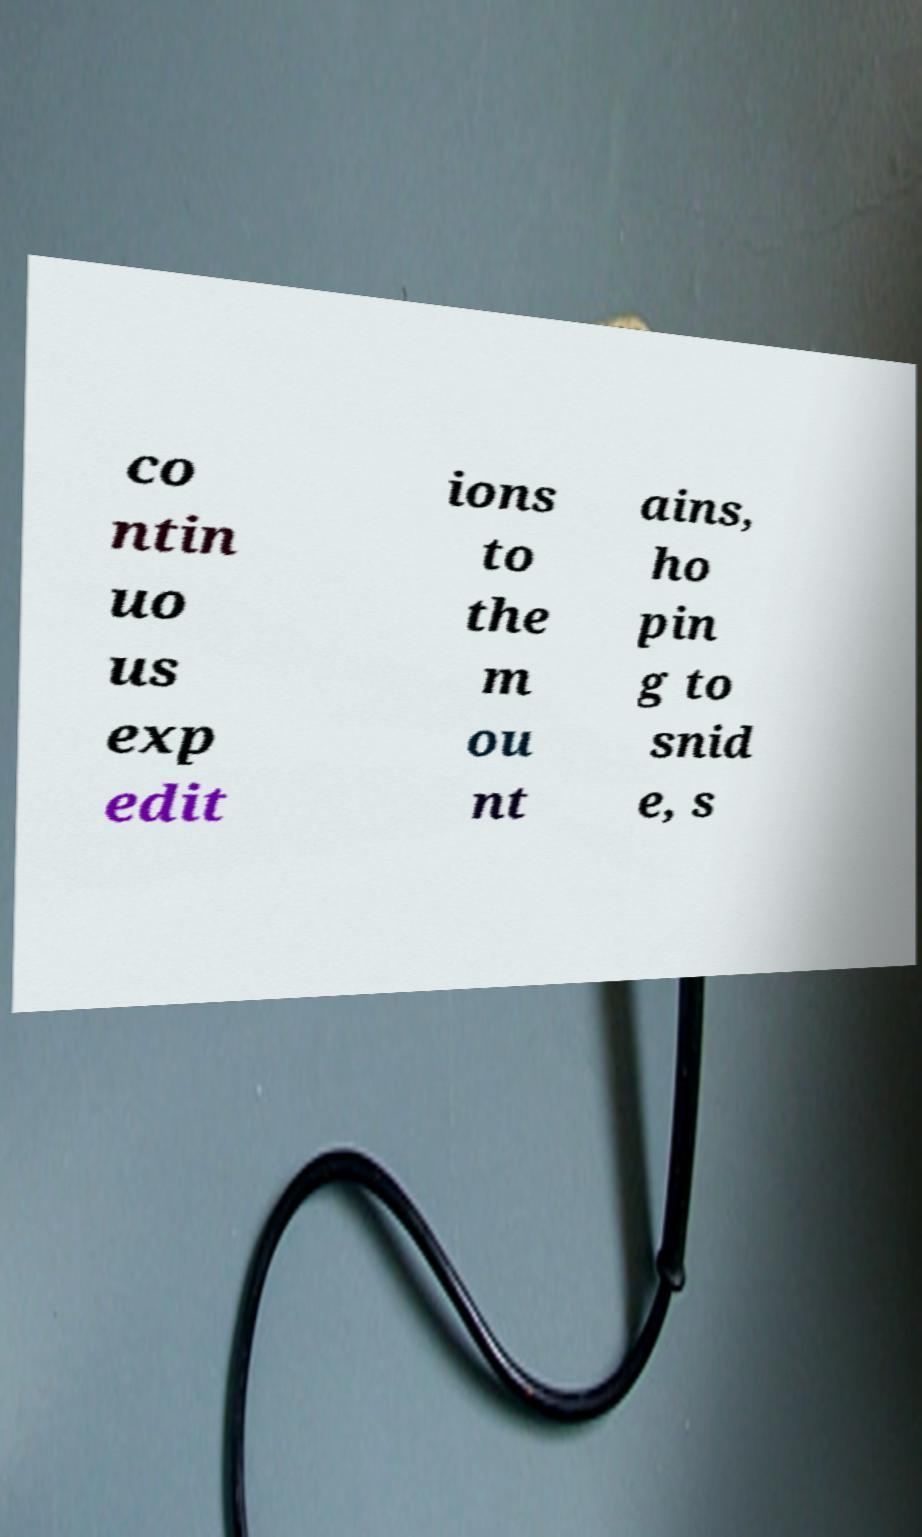There's text embedded in this image that I need extracted. Can you transcribe it verbatim? co ntin uo us exp edit ions to the m ou nt ains, ho pin g to snid e, s 